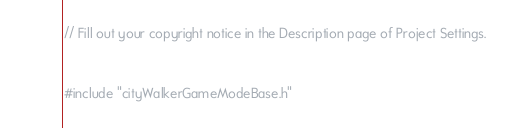<code> <loc_0><loc_0><loc_500><loc_500><_C++_>// Fill out your copyright notice in the Description page of Project Settings.


#include "cityWalkerGameModeBase.h"

</code> 